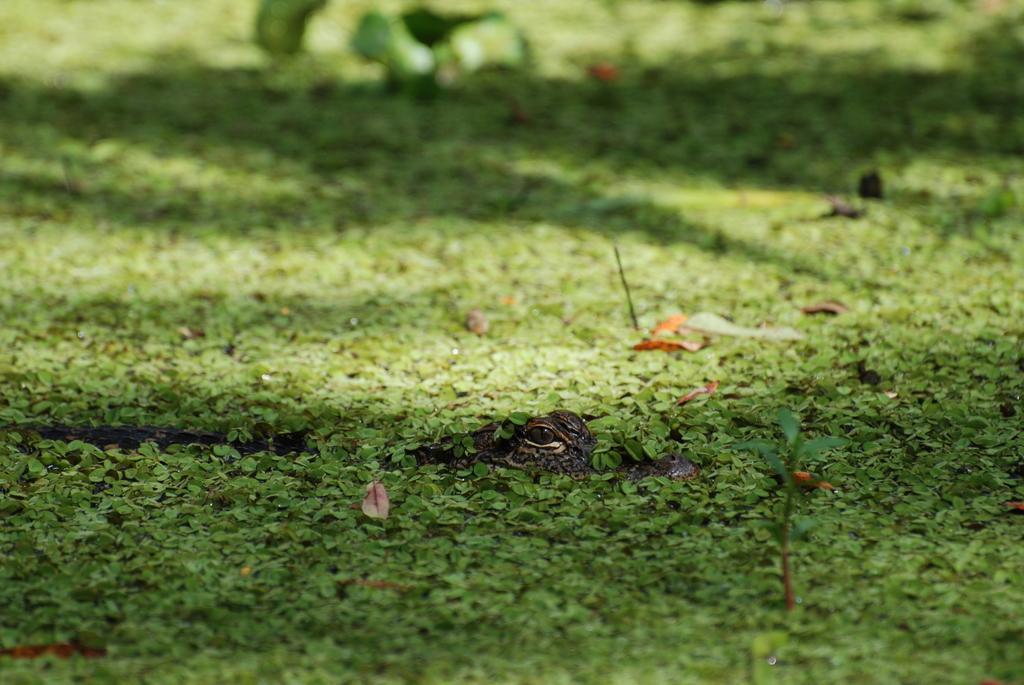Please provide a concise description of this image. In this image we can see there is a crocodile on the surface of the leaves. 